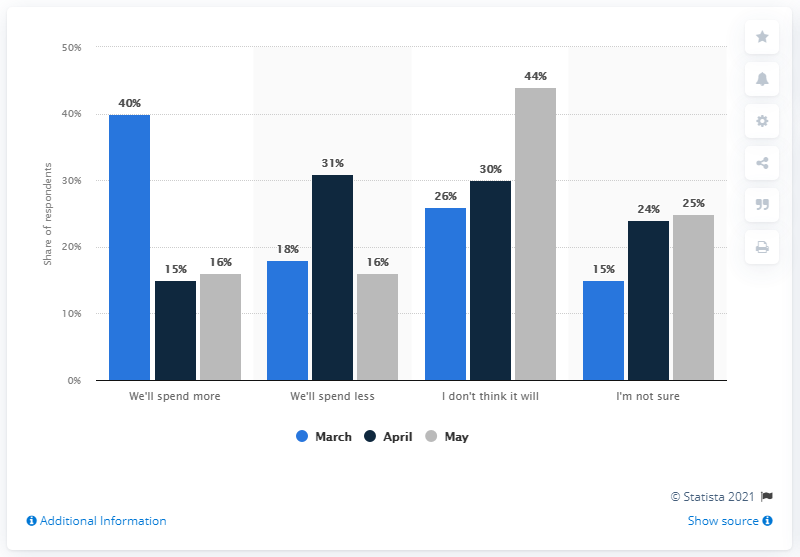Highlight a few significant elements in this photo. The difference between the highest and lowest number of blue bars in the given range is 25. People were more willing to spend more in March than they are now. 